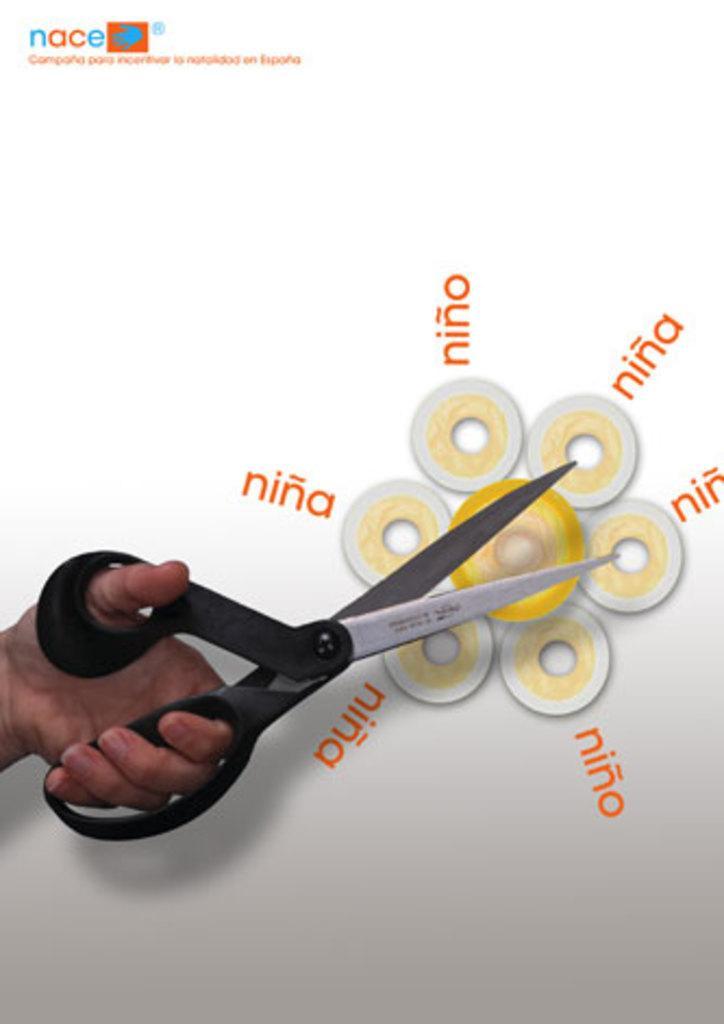In one or two sentences, can you explain what this image depicts? There is a person's hand, holding a black color scissor, near a white color hoarding, on which, there is watermark, some words and there is an image. 